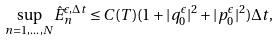Convert formula to latex. <formula><loc_0><loc_0><loc_500><loc_500>\underset { n = 1 , \dots , N } \sup \hat { E } _ { n } ^ { \epsilon , \Delta t } \leq C ( T ) ( 1 + | q _ { 0 } ^ { \epsilon } | ^ { 2 } + | p _ { 0 } ^ { \epsilon } | ^ { 2 } ) \Delta t ,</formula> 